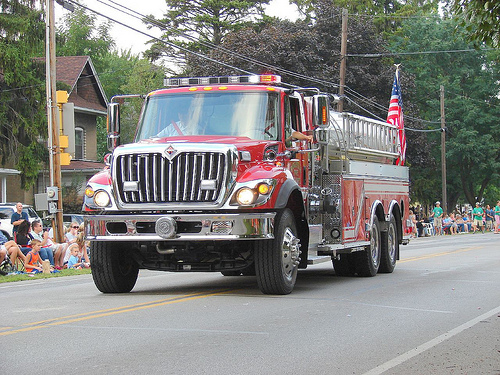<image>
Is the truck behind the people? No. The truck is not behind the people. From this viewpoint, the truck appears to be positioned elsewhere in the scene. Is the building next to the tree? Yes. The building is positioned adjacent to the tree, located nearby in the same general area. 